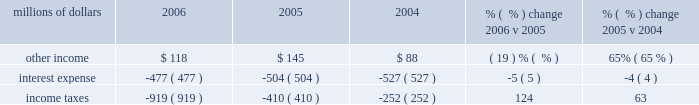Increased over 4% ( 4 % ) in 2005 , costs for trucking services provided by intermodal carriers remained flat as we substantially reduced expenses associated with network inefficiencies .
Higher diesel fuel prices increased sales and use taxes in 2005 , which resulted in higher state and local taxes .
Other contract expenses for equipment maintenance and other services increased in 2005 .
The 2005 january west coast storm and hurricanes katrina and rita also contributed to higher expenses in 2005 ( net of insurance settlements received ) .
Partially offsetting these increases was a reduction in relocation expenses as we incurred higher relocation costs associated with moving support personnel to omaha , nebraska during 2004 .
Non-operating items millions of dollars 2006 2005 2004 % (  % ) change 2006 v 2005 % (  % ) change 2005 v 2004 .
Other income 2013 lower net gains from non-operating asset sales and higher expenses due to rising interest rates associated with our sale of receivables program resulted in a reduction in other income in 2006 , which was partially offset by higher rental income for the use of our right-of-way ( including 2006 settlements of rate disputes from prior years ) and cash investment returns due to higher interest rates .
In 2005 , other income increased largely as a result of higher gains from real estate sales partially offset by higher expenses due to rising interest rates associated with our sale of receivables program .
Interest expense 2013 lower interest expense in 2006 and 2005 was primarily due to declining weighted-average debt levels of $ 7.1 billion , $ 7.8 billion , and $ 8.1 billion in 2006 , 2005 , and 2004 , respectively .
A higher effective interest rate of 6.7% ( 6.7 % ) in 2006 , compared to 6.5% ( 6.5 % ) in both 2005 and 2004 , partially offset the effects of the declining debt level .
Income taxes 2013 income tax expense was $ 509 million higher in 2006 than 2005 .
Higher pre-tax income resulted in additional taxes of $ 414 million and $ 118 million of the increase resulted from the one-time reduction in 2005 described below .
Our effective tax rate was 36.4% ( 36.4 % ) and 28.6% ( 28.6 % ) in 2006 and 2005 , respectively .
Income taxes were greater in 2005 than 2004 due to higher pre-tax income partially offset by a previously reported reduction in income tax expense .
In our quarterly report on form 10-q for the quarter ended june 30 , 2005 , we reported that the corporation analyzed the impact that final settlements of pre-1995 tax years had on previously recorded estimates of deferred tax assets and liabilities .
The completed analysis of the final settlements for pre-1995 tax years , along with internal revenue service examination reports for tax years 1995 through 2002 were considered , among other things , in a review and re-evaluation of the corporation 2019s estimated deferred tax assets and liabilities as of september 30 , 2005 , resulting in an income tax expense reduction of $ 118 million in .
What was the net change in other income from 2004 to 2005 in millions? 
Computations: (145 - 88)
Answer: 57.0. Increased over 4% ( 4 % ) in 2005 , costs for trucking services provided by intermodal carriers remained flat as we substantially reduced expenses associated with network inefficiencies .
Higher diesel fuel prices increased sales and use taxes in 2005 , which resulted in higher state and local taxes .
Other contract expenses for equipment maintenance and other services increased in 2005 .
The 2005 january west coast storm and hurricanes katrina and rita also contributed to higher expenses in 2005 ( net of insurance settlements received ) .
Partially offsetting these increases was a reduction in relocation expenses as we incurred higher relocation costs associated with moving support personnel to omaha , nebraska during 2004 .
Non-operating items millions of dollars 2006 2005 2004 % (  % ) change 2006 v 2005 % (  % ) change 2005 v 2004 .
Other income 2013 lower net gains from non-operating asset sales and higher expenses due to rising interest rates associated with our sale of receivables program resulted in a reduction in other income in 2006 , which was partially offset by higher rental income for the use of our right-of-way ( including 2006 settlements of rate disputes from prior years ) and cash investment returns due to higher interest rates .
In 2005 , other income increased largely as a result of higher gains from real estate sales partially offset by higher expenses due to rising interest rates associated with our sale of receivables program .
Interest expense 2013 lower interest expense in 2006 and 2005 was primarily due to declining weighted-average debt levels of $ 7.1 billion , $ 7.8 billion , and $ 8.1 billion in 2006 , 2005 , and 2004 , respectively .
A higher effective interest rate of 6.7% ( 6.7 % ) in 2006 , compared to 6.5% ( 6.5 % ) in both 2005 and 2004 , partially offset the effects of the declining debt level .
Income taxes 2013 income tax expense was $ 509 million higher in 2006 than 2005 .
Higher pre-tax income resulted in additional taxes of $ 414 million and $ 118 million of the increase resulted from the one-time reduction in 2005 described below .
Our effective tax rate was 36.4% ( 36.4 % ) and 28.6% ( 28.6 % ) in 2006 and 2005 , respectively .
Income taxes were greater in 2005 than 2004 due to higher pre-tax income partially offset by a previously reported reduction in income tax expense .
In our quarterly report on form 10-q for the quarter ended june 30 , 2005 , we reported that the corporation analyzed the impact that final settlements of pre-1995 tax years had on previously recorded estimates of deferred tax assets and liabilities .
The completed analysis of the final settlements for pre-1995 tax years , along with internal revenue service examination reports for tax years 1995 through 2002 were considered , among other things , in a review and re-evaluation of the corporation 2019s estimated deferred tax assets and liabilities as of september 30 , 2005 , resulting in an income tax expense reduction of $ 118 million in .
What was the net change in other income from 2004 to 2005 in millions? 
Computations: (118 - 145)
Answer: -27.0. 